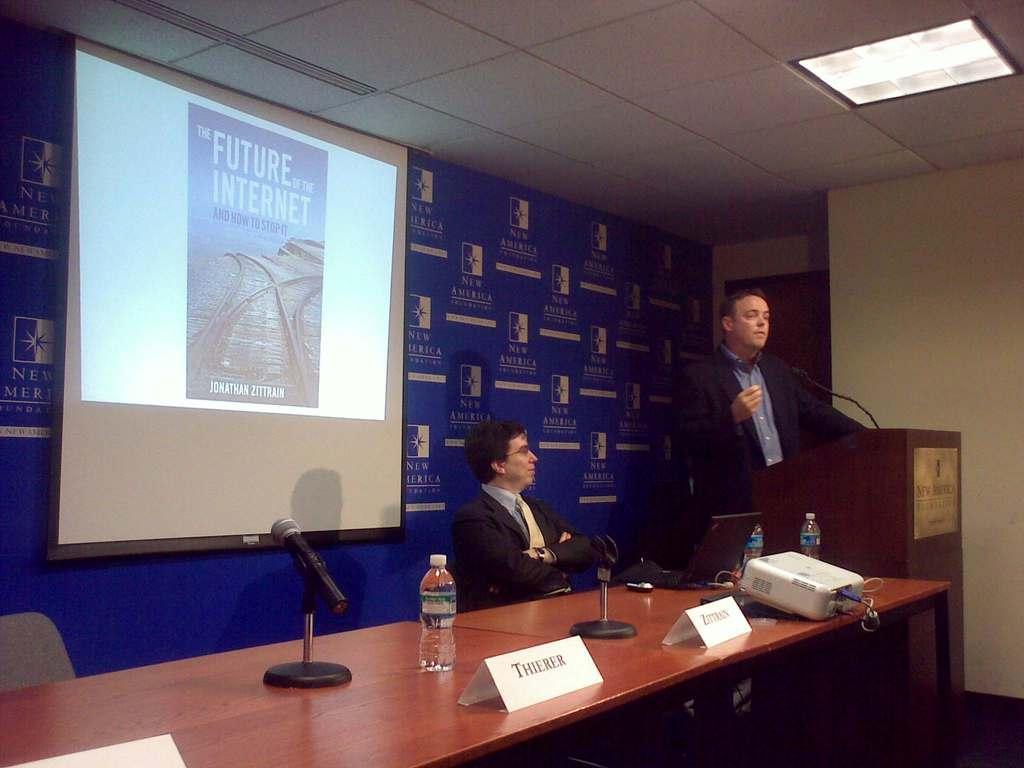Provide a one-sentence caption for the provided image. a man at a meeting with the future of the internet behind him. 